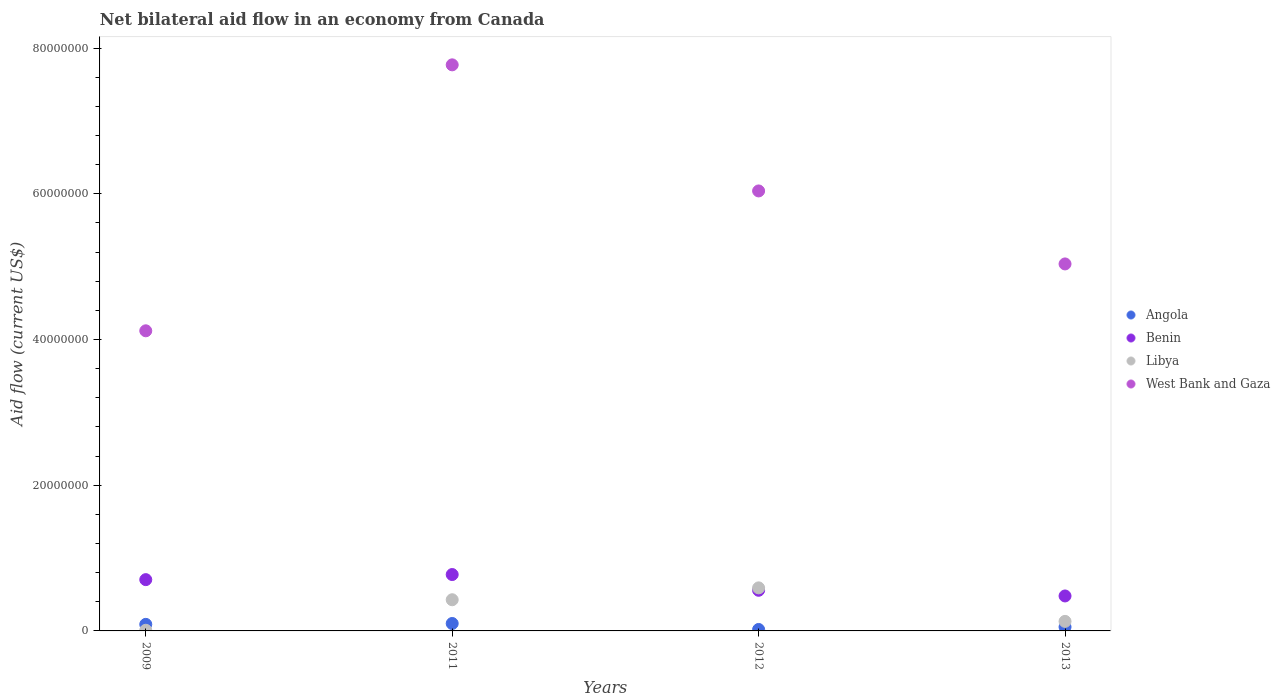How many different coloured dotlines are there?
Keep it short and to the point. 4. Is the number of dotlines equal to the number of legend labels?
Keep it short and to the point. Yes. What is the net bilateral aid flow in Angola in 2009?
Keep it short and to the point. 9.00e+05. Across all years, what is the maximum net bilateral aid flow in Angola?
Ensure brevity in your answer.  1.02e+06. Across all years, what is the minimum net bilateral aid flow in Libya?
Your answer should be very brief. 9.00e+04. In which year was the net bilateral aid flow in Angola minimum?
Offer a very short reply. 2012. What is the total net bilateral aid flow in West Bank and Gaza in the graph?
Provide a short and direct response. 2.30e+08. What is the difference between the net bilateral aid flow in West Bank and Gaza in 2009 and that in 2013?
Give a very brief answer. -9.18e+06. What is the difference between the net bilateral aid flow in Angola in 2011 and the net bilateral aid flow in Benin in 2013?
Ensure brevity in your answer.  -3.78e+06. What is the average net bilateral aid flow in Libya per year?
Give a very brief answer. 2.90e+06. In the year 2011, what is the difference between the net bilateral aid flow in Libya and net bilateral aid flow in Benin?
Provide a succinct answer. -3.46e+06. What is the ratio of the net bilateral aid flow in Benin in 2009 to that in 2013?
Offer a terse response. 1.47. Is the net bilateral aid flow in Benin in 2009 less than that in 2012?
Your answer should be very brief. No. What is the difference between the highest and the lowest net bilateral aid flow in Benin?
Offer a very short reply. 2.94e+06. Is it the case that in every year, the sum of the net bilateral aid flow in Benin and net bilateral aid flow in Angola  is greater than the sum of net bilateral aid flow in Libya and net bilateral aid flow in West Bank and Gaza?
Provide a succinct answer. No. Is the net bilateral aid flow in Benin strictly less than the net bilateral aid flow in Libya over the years?
Give a very brief answer. No. How many years are there in the graph?
Give a very brief answer. 4. What is the difference between two consecutive major ticks on the Y-axis?
Give a very brief answer. 2.00e+07. Does the graph contain grids?
Make the answer very short. No. How many legend labels are there?
Make the answer very short. 4. How are the legend labels stacked?
Keep it short and to the point. Vertical. What is the title of the graph?
Offer a terse response. Net bilateral aid flow in an economy from Canada. Does "Nigeria" appear as one of the legend labels in the graph?
Give a very brief answer. No. What is the Aid flow (current US$) in Benin in 2009?
Provide a short and direct response. 7.04e+06. What is the Aid flow (current US$) of Libya in 2009?
Ensure brevity in your answer.  9.00e+04. What is the Aid flow (current US$) of West Bank and Gaza in 2009?
Provide a short and direct response. 4.12e+07. What is the Aid flow (current US$) in Angola in 2011?
Offer a very short reply. 1.02e+06. What is the Aid flow (current US$) in Benin in 2011?
Give a very brief answer. 7.74e+06. What is the Aid flow (current US$) in Libya in 2011?
Provide a succinct answer. 4.28e+06. What is the Aid flow (current US$) of West Bank and Gaza in 2011?
Keep it short and to the point. 7.77e+07. What is the Aid flow (current US$) of Benin in 2012?
Give a very brief answer. 5.58e+06. What is the Aid flow (current US$) of Libya in 2012?
Offer a terse response. 5.91e+06. What is the Aid flow (current US$) of West Bank and Gaza in 2012?
Ensure brevity in your answer.  6.04e+07. What is the Aid flow (current US$) of Angola in 2013?
Your answer should be very brief. 5.40e+05. What is the Aid flow (current US$) in Benin in 2013?
Give a very brief answer. 4.80e+06. What is the Aid flow (current US$) of Libya in 2013?
Your response must be concise. 1.31e+06. What is the Aid flow (current US$) in West Bank and Gaza in 2013?
Offer a very short reply. 5.04e+07. Across all years, what is the maximum Aid flow (current US$) in Angola?
Keep it short and to the point. 1.02e+06. Across all years, what is the maximum Aid flow (current US$) in Benin?
Your answer should be compact. 7.74e+06. Across all years, what is the maximum Aid flow (current US$) in Libya?
Offer a very short reply. 5.91e+06. Across all years, what is the maximum Aid flow (current US$) of West Bank and Gaza?
Ensure brevity in your answer.  7.77e+07. Across all years, what is the minimum Aid flow (current US$) in Angola?
Give a very brief answer. 2.00e+05. Across all years, what is the minimum Aid flow (current US$) in Benin?
Your response must be concise. 4.80e+06. Across all years, what is the minimum Aid flow (current US$) in West Bank and Gaza?
Give a very brief answer. 4.12e+07. What is the total Aid flow (current US$) in Angola in the graph?
Provide a short and direct response. 2.66e+06. What is the total Aid flow (current US$) in Benin in the graph?
Provide a succinct answer. 2.52e+07. What is the total Aid flow (current US$) of Libya in the graph?
Your response must be concise. 1.16e+07. What is the total Aid flow (current US$) of West Bank and Gaza in the graph?
Provide a short and direct response. 2.30e+08. What is the difference between the Aid flow (current US$) in Benin in 2009 and that in 2011?
Provide a short and direct response. -7.00e+05. What is the difference between the Aid flow (current US$) in Libya in 2009 and that in 2011?
Give a very brief answer. -4.19e+06. What is the difference between the Aid flow (current US$) in West Bank and Gaza in 2009 and that in 2011?
Give a very brief answer. -3.65e+07. What is the difference between the Aid flow (current US$) in Benin in 2009 and that in 2012?
Keep it short and to the point. 1.46e+06. What is the difference between the Aid flow (current US$) of Libya in 2009 and that in 2012?
Your response must be concise. -5.82e+06. What is the difference between the Aid flow (current US$) of West Bank and Gaza in 2009 and that in 2012?
Provide a succinct answer. -1.92e+07. What is the difference between the Aid flow (current US$) of Angola in 2009 and that in 2013?
Your answer should be very brief. 3.60e+05. What is the difference between the Aid flow (current US$) in Benin in 2009 and that in 2013?
Make the answer very short. 2.24e+06. What is the difference between the Aid flow (current US$) of Libya in 2009 and that in 2013?
Your answer should be compact. -1.22e+06. What is the difference between the Aid flow (current US$) in West Bank and Gaza in 2009 and that in 2013?
Make the answer very short. -9.18e+06. What is the difference between the Aid flow (current US$) in Angola in 2011 and that in 2012?
Provide a succinct answer. 8.20e+05. What is the difference between the Aid flow (current US$) in Benin in 2011 and that in 2012?
Provide a short and direct response. 2.16e+06. What is the difference between the Aid flow (current US$) of Libya in 2011 and that in 2012?
Give a very brief answer. -1.63e+06. What is the difference between the Aid flow (current US$) in West Bank and Gaza in 2011 and that in 2012?
Keep it short and to the point. 1.73e+07. What is the difference between the Aid flow (current US$) in Benin in 2011 and that in 2013?
Your response must be concise. 2.94e+06. What is the difference between the Aid flow (current US$) in Libya in 2011 and that in 2013?
Offer a very short reply. 2.97e+06. What is the difference between the Aid flow (current US$) in West Bank and Gaza in 2011 and that in 2013?
Your answer should be compact. 2.73e+07. What is the difference between the Aid flow (current US$) in Angola in 2012 and that in 2013?
Ensure brevity in your answer.  -3.40e+05. What is the difference between the Aid flow (current US$) in Benin in 2012 and that in 2013?
Offer a terse response. 7.80e+05. What is the difference between the Aid flow (current US$) of Libya in 2012 and that in 2013?
Provide a succinct answer. 4.60e+06. What is the difference between the Aid flow (current US$) of West Bank and Gaza in 2012 and that in 2013?
Make the answer very short. 1.00e+07. What is the difference between the Aid flow (current US$) of Angola in 2009 and the Aid flow (current US$) of Benin in 2011?
Offer a very short reply. -6.84e+06. What is the difference between the Aid flow (current US$) of Angola in 2009 and the Aid flow (current US$) of Libya in 2011?
Ensure brevity in your answer.  -3.38e+06. What is the difference between the Aid flow (current US$) in Angola in 2009 and the Aid flow (current US$) in West Bank and Gaza in 2011?
Your answer should be very brief. -7.68e+07. What is the difference between the Aid flow (current US$) of Benin in 2009 and the Aid flow (current US$) of Libya in 2011?
Your answer should be very brief. 2.76e+06. What is the difference between the Aid flow (current US$) of Benin in 2009 and the Aid flow (current US$) of West Bank and Gaza in 2011?
Keep it short and to the point. -7.07e+07. What is the difference between the Aid flow (current US$) in Libya in 2009 and the Aid flow (current US$) in West Bank and Gaza in 2011?
Give a very brief answer. -7.76e+07. What is the difference between the Aid flow (current US$) of Angola in 2009 and the Aid flow (current US$) of Benin in 2012?
Your answer should be compact. -4.68e+06. What is the difference between the Aid flow (current US$) in Angola in 2009 and the Aid flow (current US$) in Libya in 2012?
Offer a very short reply. -5.01e+06. What is the difference between the Aid flow (current US$) of Angola in 2009 and the Aid flow (current US$) of West Bank and Gaza in 2012?
Make the answer very short. -5.95e+07. What is the difference between the Aid flow (current US$) of Benin in 2009 and the Aid flow (current US$) of Libya in 2012?
Ensure brevity in your answer.  1.13e+06. What is the difference between the Aid flow (current US$) in Benin in 2009 and the Aid flow (current US$) in West Bank and Gaza in 2012?
Keep it short and to the point. -5.34e+07. What is the difference between the Aid flow (current US$) in Libya in 2009 and the Aid flow (current US$) in West Bank and Gaza in 2012?
Offer a very short reply. -6.03e+07. What is the difference between the Aid flow (current US$) of Angola in 2009 and the Aid flow (current US$) of Benin in 2013?
Keep it short and to the point. -3.90e+06. What is the difference between the Aid flow (current US$) in Angola in 2009 and the Aid flow (current US$) in Libya in 2013?
Provide a short and direct response. -4.10e+05. What is the difference between the Aid flow (current US$) in Angola in 2009 and the Aid flow (current US$) in West Bank and Gaza in 2013?
Your answer should be compact. -4.95e+07. What is the difference between the Aid flow (current US$) of Benin in 2009 and the Aid flow (current US$) of Libya in 2013?
Offer a very short reply. 5.73e+06. What is the difference between the Aid flow (current US$) of Benin in 2009 and the Aid flow (current US$) of West Bank and Gaza in 2013?
Keep it short and to the point. -4.33e+07. What is the difference between the Aid flow (current US$) of Libya in 2009 and the Aid flow (current US$) of West Bank and Gaza in 2013?
Ensure brevity in your answer.  -5.03e+07. What is the difference between the Aid flow (current US$) in Angola in 2011 and the Aid flow (current US$) in Benin in 2012?
Give a very brief answer. -4.56e+06. What is the difference between the Aid flow (current US$) of Angola in 2011 and the Aid flow (current US$) of Libya in 2012?
Your response must be concise. -4.89e+06. What is the difference between the Aid flow (current US$) in Angola in 2011 and the Aid flow (current US$) in West Bank and Gaza in 2012?
Ensure brevity in your answer.  -5.94e+07. What is the difference between the Aid flow (current US$) of Benin in 2011 and the Aid flow (current US$) of Libya in 2012?
Make the answer very short. 1.83e+06. What is the difference between the Aid flow (current US$) of Benin in 2011 and the Aid flow (current US$) of West Bank and Gaza in 2012?
Make the answer very short. -5.27e+07. What is the difference between the Aid flow (current US$) of Libya in 2011 and the Aid flow (current US$) of West Bank and Gaza in 2012?
Make the answer very short. -5.61e+07. What is the difference between the Aid flow (current US$) of Angola in 2011 and the Aid flow (current US$) of Benin in 2013?
Ensure brevity in your answer.  -3.78e+06. What is the difference between the Aid flow (current US$) in Angola in 2011 and the Aid flow (current US$) in Libya in 2013?
Your response must be concise. -2.90e+05. What is the difference between the Aid flow (current US$) of Angola in 2011 and the Aid flow (current US$) of West Bank and Gaza in 2013?
Give a very brief answer. -4.94e+07. What is the difference between the Aid flow (current US$) of Benin in 2011 and the Aid flow (current US$) of Libya in 2013?
Offer a very short reply. 6.43e+06. What is the difference between the Aid flow (current US$) of Benin in 2011 and the Aid flow (current US$) of West Bank and Gaza in 2013?
Your response must be concise. -4.26e+07. What is the difference between the Aid flow (current US$) of Libya in 2011 and the Aid flow (current US$) of West Bank and Gaza in 2013?
Your answer should be very brief. -4.61e+07. What is the difference between the Aid flow (current US$) of Angola in 2012 and the Aid flow (current US$) of Benin in 2013?
Provide a succinct answer. -4.60e+06. What is the difference between the Aid flow (current US$) of Angola in 2012 and the Aid flow (current US$) of Libya in 2013?
Provide a succinct answer. -1.11e+06. What is the difference between the Aid flow (current US$) in Angola in 2012 and the Aid flow (current US$) in West Bank and Gaza in 2013?
Give a very brief answer. -5.02e+07. What is the difference between the Aid flow (current US$) of Benin in 2012 and the Aid flow (current US$) of Libya in 2013?
Keep it short and to the point. 4.27e+06. What is the difference between the Aid flow (current US$) of Benin in 2012 and the Aid flow (current US$) of West Bank and Gaza in 2013?
Offer a very short reply. -4.48e+07. What is the difference between the Aid flow (current US$) in Libya in 2012 and the Aid flow (current US$) in West Bank and Gaza in 2013?
Your answer should be compact. -4.45e+07. What is the average Aid flow (current US$) in Angola per year?
Provide a short and direct response. 6.65e+05. What is the average Aid flow (current US$) of Benin per year?
Provide a succinct answer. 6.29e+06. What is the average Aid flow (current US$) in Libya per year?
Your answer should be compact. 2.90e+06. What is the average Aid flow (current US$) in West Bank and Gaza per year?
Your answer should be very brief. 5.74e+07. In the year 2009, what is the difference between the Aid flow (current US$) in Angola and Aid flow (current US$) in Benin?
Your response must be concise. -6.14e+06. In the year 2009, what is the difference between the Aid flow (current US$) in Angola and Aid flow (current US$) in Libya?
Provide a succinct answer. 8.10e+05. In the year 2009, what is the difference between the Aid flow (current US$) in Angola and Aid flow (current US$) in West Bank and Gaza?
Ensure brevity in your answer.  -4.03e+07. In the year 2009, what is the difference between the Aid flow (current US$) in Benin and Aid flow (current US$) in Libya?
Offer a very short reply. 6.95e+06. In the year 2009, what is the difference between the Aid flow (current US$) in Benin and Aid flow (current US$) in West Bank and Gaza?
Make the answer very short. -3.42e+07. In the year 2009, what is the difference between the Aid flow (current US$) in Libya and Aid flow (current US$) in West Bank and Gaza?
Your answer should be compact. -4.11e+07. In the year 2011, what is the difference between the Aid flow (current US$) of Angola and Aid flow (current US$) of Benin?
Your answer should be compact. -6.72e+06. In the year 2011, what is the difference between the Aid flow (current US$) in Angola and Aid flow (current US$) in Libya?
Your answer should be compact. -3.26e+06. In the year 2011, what is the difference between the Aid flow (current US$) in Angola and Aid flow (current US$) in West Bank and Gaza?
Your answer should be compact. -7.67e+07. In the year 2011, what is the difference between the Aid flow (current US$) in Benin and Aid flow (current US$) in Libya?
Your answer should be compact. 3.46e+06. In the year 2011, what is the difference between the Aid flow (current US$) in Benin and Aid flow (current US$) in West Bank and Gaza?
Offer a terse response. -7.00e+07. In the year 2011, what is the difference between the Aid flow (current US$) of Libya and Aid flow (current US$) of West Bank and Gaza?
Offer a very short reply. -7.34e+07. In the year 2012, what is the difference between the Aid flow (current US$) in Angola and Aid flow (current US$) in Benin?
Your answer should be compact. -5.38e+06. In the year 2012, what is the difference between the Aid flow (current US$) of Angola and Aid flow (current US$) of Libya?
Provide a short and direct response. -5.71e+06. In the year 2012, what is the difference between the Aid flow (current US$) of Angola and Aid flow (current US$) of West Bank and Gaza?
Give a very brief answer. -6.02e+07. In the year 2012, what is the difference between the Aid flow (current US$) of Benin and Aid flow (current US$) of Libya?
Your response must be concise. -3.30e+05. In the year 2012, what is the difference between the Aid flow (current US$) of Benin and Aid flow (current US$) of West Bank and Gaza?
Offer a very short reply. -5.48e+07. In the year 2012, what is the difference between the Aid flow (current US$) in Libya and Aid flow (current US$) in West Bank and Gaza?
Ensure brevity in your answer.  -5.45e+07. In the year 2013, what is the difference between the Aid flow (current US$) in Angola and Aid flow (current US$) in Benin?
Your response must be concise. -4.26e+06. In the year 2013, what is the difference between the Aid flow (current US$) of Angola and Aid flow (current US$) of Libya?
Keep it short and to the point. -7.70e+05. In the year 2013, what is the difference between the Aid flow (current US$) in Angola and Aid flow (current US$) in West Bank and Gaza?
Give a very brief answer. -4.98e+07. In the year 2013, what is the difference between the Aid flow (current US$) of Benin and Aid flow (current US$) of Libya?
Your response must be concise. 3.49e+06. In the year 2013, what is the difference between the Aid flow (current US$) of Benin and Aid flow (current US$) of West Bank and Gaza?
Offer a terse response. -4.56e+07. In the year 2013, what is the difference between the Aid flow (current US$) in Libya and Aid flow (current US$) in West Bank and Gaza?
Provide a succinct answer. -4.91e+07. What is the ratio of the Aid flow (current US$) of Angola in 2009 to that in 2011?
Provide a succinct answer. 0.88. What is the ratio of the Aid flow (current US$) in Benin in 2009 to that in 2011?
Your answer should be compact. 0.91. What is the ratio of the Aid flow (current US$) of Libya in 2009 to that in 2011?
Keep it short and to the point. 0.02. What is the ratio of the Aid flow (current US$) of West Bank and Gaza in 2009 to that in 2011?
Provide a short and direct response. 0.53. What is the ratio of the Aid flow (current US$) of Angola in 2009 to that in 2012?
Your answer should be very brief. 4.5. What is the ratio of the Aid flow (current US$) of Benin in 2009 to that in 2012?
Provide a succinct answer. 1.26. What is the ratio of the Aid flow (current US$) in Libya in 2009 to that in 2012?
Provide a short and direct response. 0.02. What is the ratio of the Aid flow (current US$) of West Bank and Gaza in 2009 to that in 2012?
Offer a terse response. 0.68. What is the ratio of the Aid flow (current US$) of Angola in 2009 to that in 2013?
Your answer should be compact. 1.67. What is the ratio of the Aid flow (current US$) in Benin in 2009 to that in 2013?
Your response must be concise. 1.47. What is the ratio of the Aid flow (current US$) in Libya in 2009 to that in 2013?
Provide a short and direct response. 0.07. What is the ratio of the Aid flow (current US$) in West Bank and Gaza in 2009 to that in 2013?
Your answer should be very brief. 0.82. What is the ratio of the Aid flow (current US$) of Benin in 2011 to that in 2012?
Your response must be concise. 1.39. What is the ratio of the Aid flow (current US$) in Libya in 2011 to that in 2012?
Your response must be concise. 0.72. What is the ratio of the Aid flow (current US$) in West Bank and Gaza in 2011 to that in 2012?
Offer a terse response. 1.29. What is the ratio of the Aid flow (current US$) of Angola in 2011 to that in 2013?
Provide a succinct answer. 1.89. What is the ratio of the Aid flow (current US$) in Benin in 2011 to that in 2013?
Ensure brevity in your answer.  1.61. What is the ratio of the Aid flow (current US$) of Libya in 2011 to that in 2013?
Your answer should be very brief. 3.27. What is the ratio of the Aid flow (current US$) in West Bank and Gaza in 2011 to that in 2013?
Offer a terse response. 1.54. What is the ratio of the Aid flow (current US$) in Angola in 2012 to that in 2013?
Your response must be concise. 0.37. What is the ratio of the Aid flow (current US$) of Benin in 2012 to that in 2013?
Your answer should be compact. 1.16. What is the ratio of the Aid flow (current US$) of Libya in 2012 to that in 2013?
Offer a very short reply. 4.51. What is the ratio of the Aid flow (current US$) of West Bank and Gaza in 2012 to that in 2013?
Provide a short and direct response. 1.2. What is the difference between the highest and the second highest Aid flow (current US$) in Libya?
Your answer should be very brief. 1.63e+06. What is the difference between the highest and the second highest Aid flow (current US$) of West Bank and Gaza?
Provide a succinct answer. 1.73e+07. What is the difference between the highest and the lowest Aid flow (current US$) in Angola?
Provide a short and direct response. 8.20e+05. What is the difference between the highest and the lowest Aid flow (current US$) of Benin?
Your answer should be compact. 2.94e+06. What is the difference between the highest and the lowest Aid flow (current US$) in Libya?
Offer a terse response. 5.82e+06. What is the difference between the highest and the lowest Aid flow (current US$) in West Bank and Gaza?
Your response must be concise. 3.65e+07. 